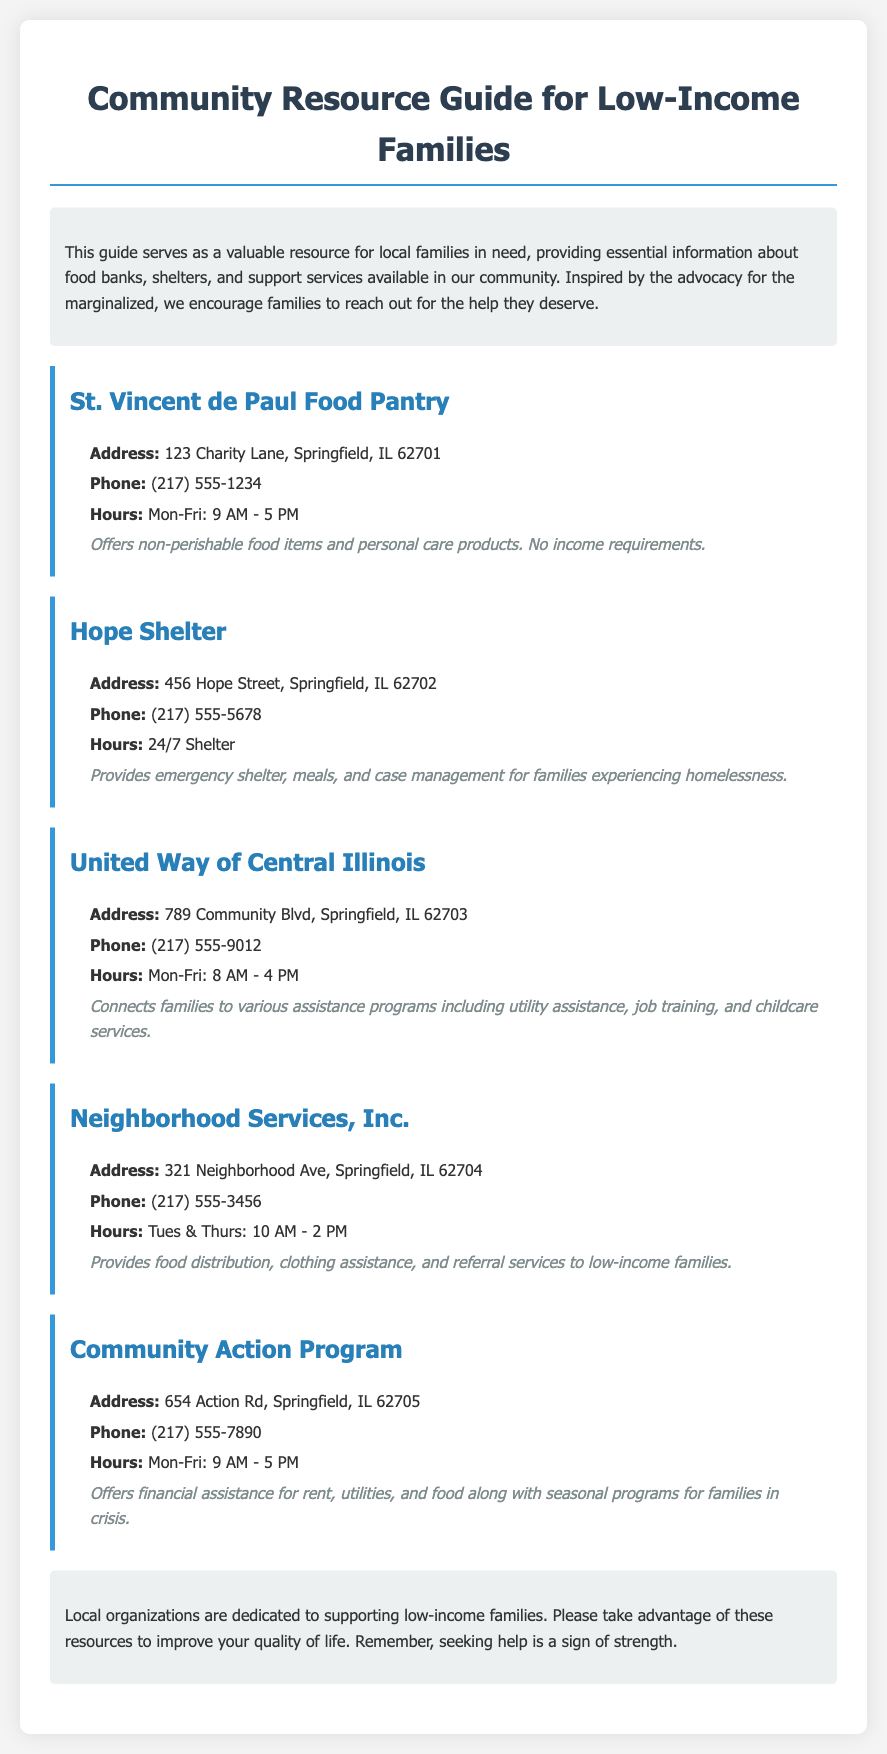What is the address of St. Vincent de Paul Food Pantry? The address is listed in the document under the specific resource section for St. Vincent de Paul Food Pantry.
Answer: 123 Charity Lane, Springfield, IL 62701 What services does Hope Shelter provide? The document mentions the services offered by Hope Shelter, which are specified in the details section.
Answer: Emergency shelter, meals, and case management What is the phone number for United Way of Central Illinois? The phone number is explicitly mentioned in the contact details for United Way of Central Illinois.
Answer: (217) 555-9012 How many hours a week is the Neighborhood Services, Inc. open? The hours of operation for Neighborhood Services, Inc. are listed in the document, allowing us to calculate the total.
Answer: 4 hours What type of assistance does Community Action Program offer? The services of Community Action Program are outlined in the document, detailing the types of assistance available.
Answer: Financial assistance for rent, utilities, and food Which organization provides food distribution and clothing assistance? This information can be found in the services section of the Neighborhood Services, Inc. resource.
Answer: Neighborhood Services, Inc How many local organizations are mentioned in the resource guide? The document lists five distinct organizations, which can be counted.
Answer: Five What is the general purpose of this Community Resource Guide? This can be found in the introductory paragraph explaining the guide's intention.
Answer: To provide essential information for local families in need What is meant by "seeking help is a sign of strength"? This phrase appears in the conclusion, conveying the document's encouragement for families to reach out for support.
Answer: Encouragement for seeking help 